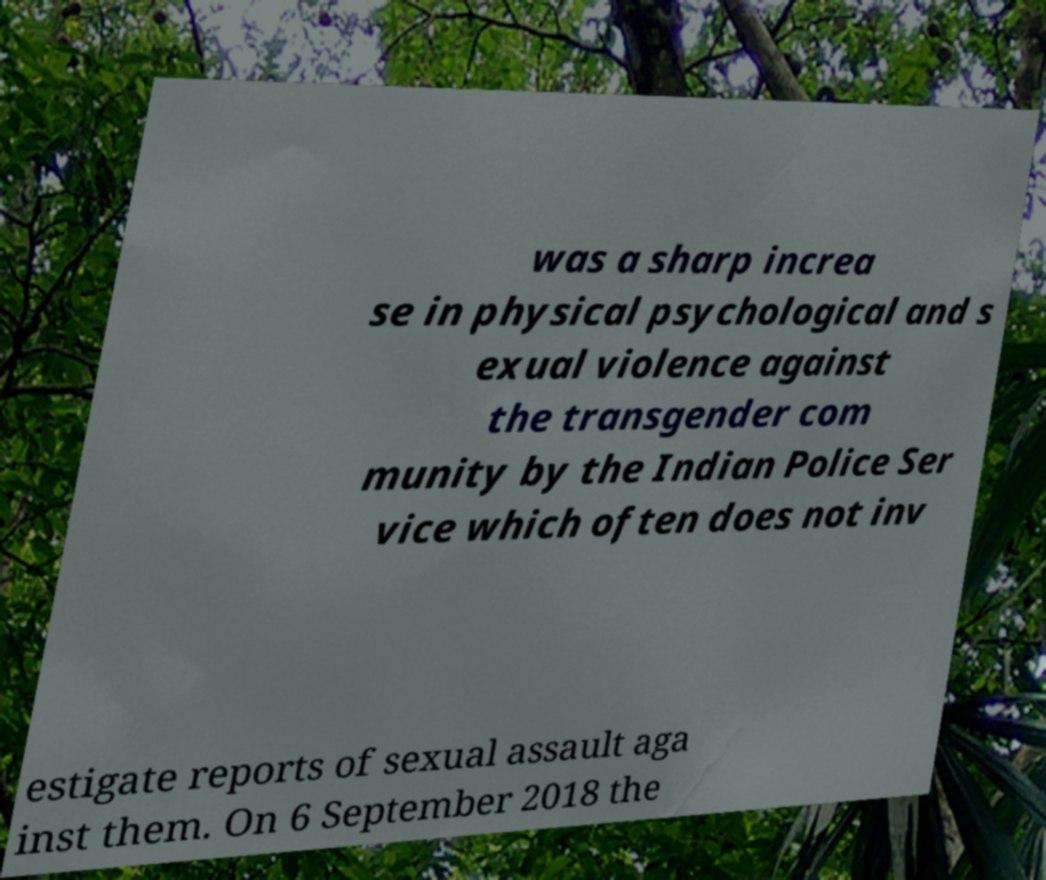Could you extract and type out the text from this image? was a sharp increa se in physical psychological and s exual violence against the transgender com munity by the Indian Police Ser vice which often does not inv estigate reports of sexual assault aga inst them. On 6 September 2018 the 